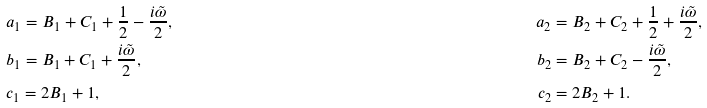Convert formula to latex. <formula><loc_0><loc_0><loc_500><loc_500>& a _ { 1 } = B _ { 1 } + C _ { 1 } + \frac { 1 } { 2 } - \frac { i \tilde { \omega } } { 2 } , \quad & a _ { 2 } & = B _ { 2 } + C _ { 2 } + \frac { 1 } { 2 } + \frac { i \tilde { \omega } } { 2 } , \\ & b _ { 1 } = B _ { 1 } + C _ { 1 } + \frac { i \tilde { \omega } } { 2 } , \quad & b _ { 2 } & = B _ { 2 } + C _ { 2 } - \frac { i \tilde { \omega } } { 2 } , \\ & c _ { 1 } = 2 B _ { 1 } + 1 , \quad & c _ { 2 } & = 2 B _ { 2 } + 1 .</formula> 